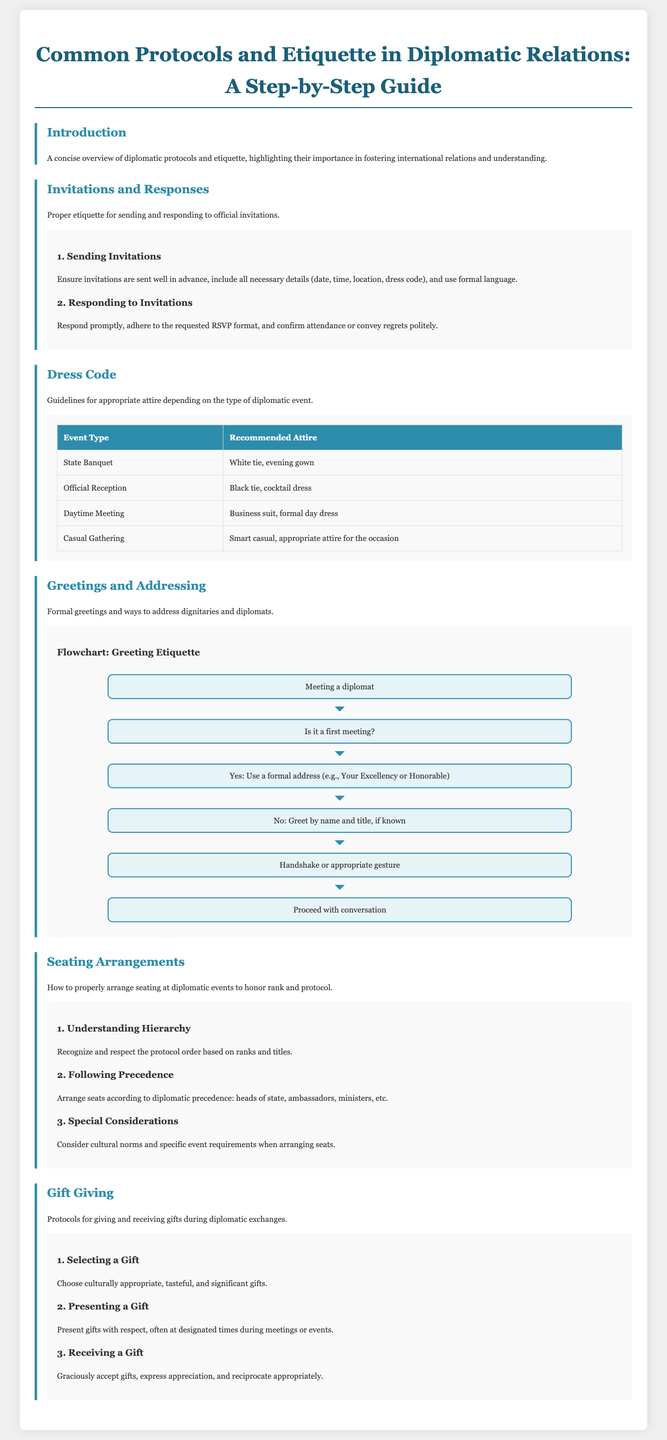what is the recommended attire for a State Banquet? The document lists the recommended attire for a State Banquet as "White tie, evening gown."
Answer: White tie, evening gown how should invitations be responded to? The document states that invitations should be responded to promptly and in the requested RSVP format.
Answer: Promptly, RSVP format what is the first step in greeting a diplomat according to the flowchart? The flowchart indicates that the first step when greeting a diplomat is "Meeting a diplomat."
Answer: Meeting a diplomat what is the third step in presenting a gift? The document mentions that the third step in presenting a gift is to "Graciously accept gifts, express appreciation, and reciprocate appropriately."
Answer: Graciously accept gifts, express appreciation, and reciprocate appropriately how are seats arranged at diplomatic events? The document explains that seats should be arranged according to "diplomatic precedence."
Answer: Diplomatic precedence what is the color of the table headers for the dress code? The document specifies that the background color of the table headers is "#2d8cac."
Answer: #2d8cac what type of document is this? The structure and content of the document indicate that it is an "Informational infographic."
Answer: Informational infographic how many steps are there in the dress code section? The table in the dress code section has a total of four different event types listed.
Answer: Four what is emphasized in the introduction section? The introduction emphasizes the importance of diplomatic protocols and etiquette in fostering international relations.
Answer: Importance in fostering international relations 